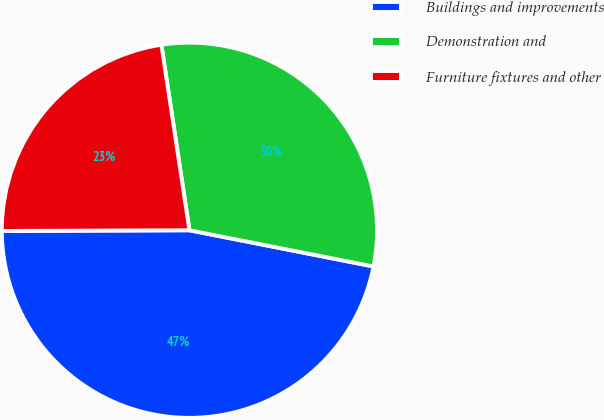<chart> <loc_0><loc_0><loc_500><loc_500><pie_chart><fcel>Buildings and improvements<fcel>Demonstration and<fcel>Furniture fixtures and other<nl><fcel>46.84%<fcel>30.48%<fcel>22.67%<nl></chart> 